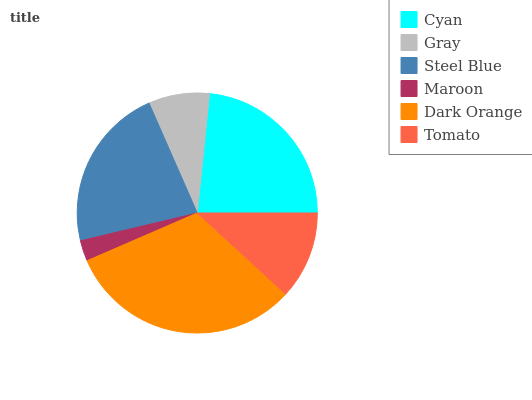Is Maroon the minimum?
Answer yes or no. Yes. Is Dark Orange the maximum?
Answer yes or no. Yes. Is Gray the minimum?
Answer yes or no. No. Is Gray the maximum?
Answer yes or no. No. Is Cyan greater than Gray?
Answer yes or no. Yes. Is Gray less than Cyan?
Answer yes or no. Yes. Is Gray greater than Cyan?
Answer yes or no. No. Is Cyan less than Gray?
Answer yes or no. No. Is Steel Blue the high median?
Answer yes or no. Yes. Is Tomato the low median?
Answer yes or no. Yes. Is Dark Orange the high median?
Answer yes or no. No. Is Dark Orange the low median?
Answer yes or no. No. 